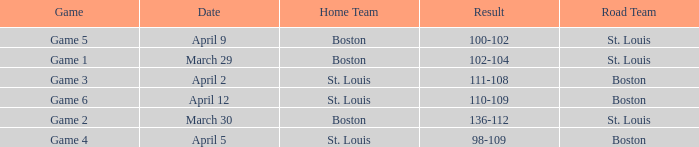What is the Result of the Game on April 9? 100-102. 